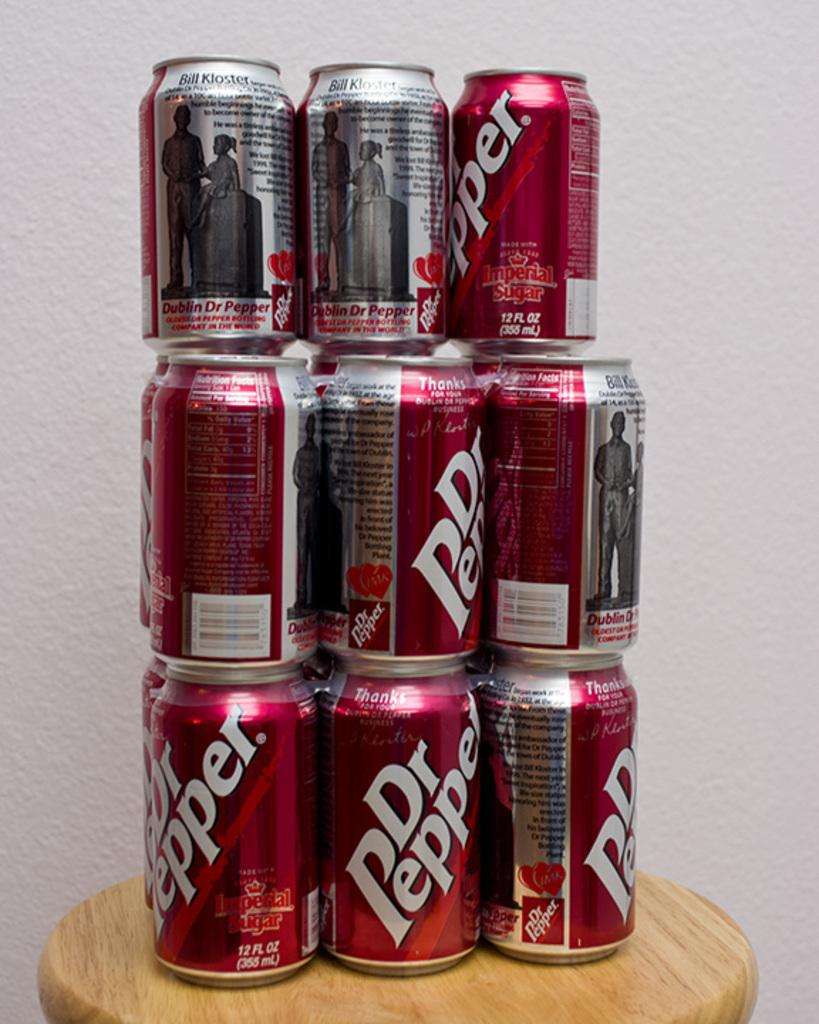<image>
Summarize the visual content of the image. Cans of Dr Pepper are stacked 3 high on a small round surface. 